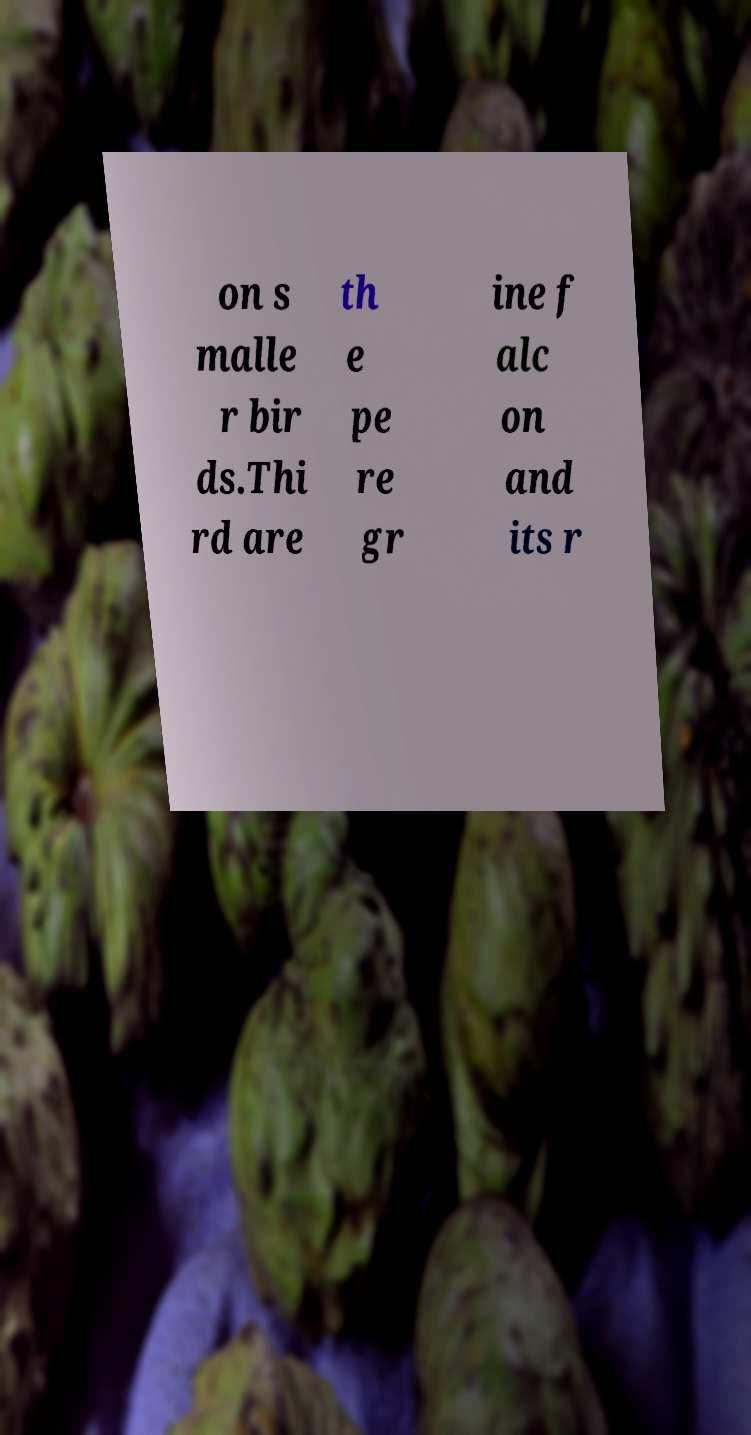I need the written content from this picture converted into text. Can you do that? on s malle r bir ds.Thi rd are th e pe re gr ine f alc on and its r 